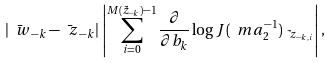<formula> <loc_0><loc_0><loc_500><loc_500>| \bar { \ w } _ { - k } - \bar { \ z } _ { - k } | \, \left | \sum _ { i = 0 } ^ { M ( \tilde { z } _ { - k } ) - 1 } \frac { \partial } { \partial b _ { k } } \log J ( \ m a _ { 2 } ^ { - 1 } ) _ { \tilde { \ z } _ { - k , i } } \right | ,</formula> 